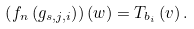Convert formula to latex. <formula><loc_0><loc_0><loc_500><loc_500>\left ( f _ { n } \left ( g _ { s , j , i } \right ) \right ) \left ( w \right ) = T _ { b _ { i } } \left ( v \right ) .</formula> 